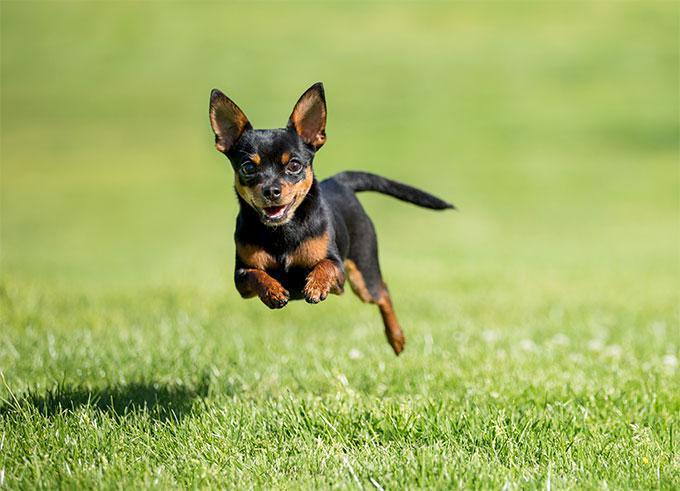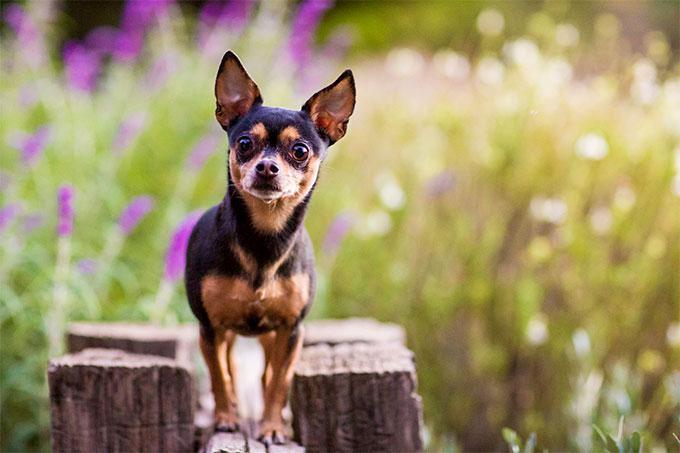The first image is the image on the left, the second image is the image on the right. Analyze the images presented: Is the assertion "The dogs in the image on the right are sitting on grass." valid? Answer yes or no. No. 